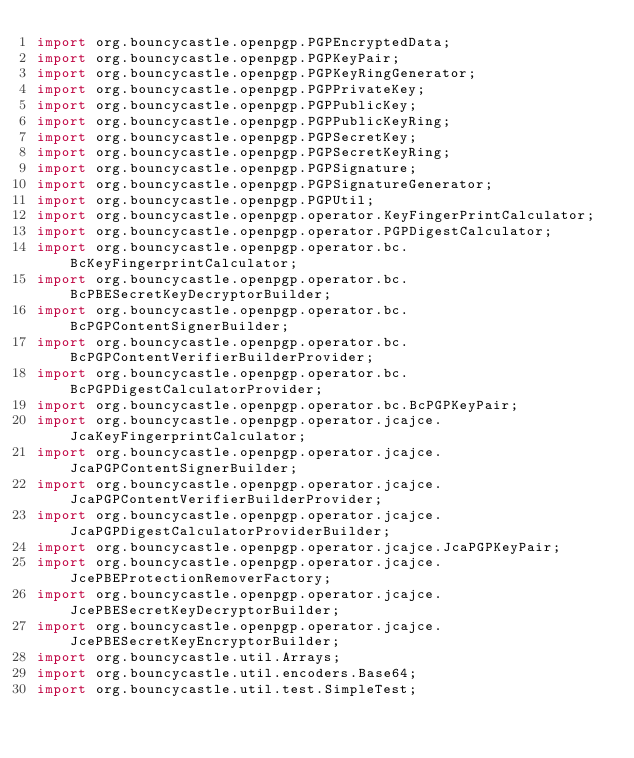<code> <loc_0><loc_0><loc_500><loc_500><_Java_>import org.bouncycastle.openpgp.PGPEncryptedData;
import org.bouncycastle.openpgp.PGPKeyPair;
import org.bouncycastle.openpgp.PGPKeyRingGenerator;
import org.bouncycastle.openpgp.PGPPrivateKey;
import org.bouncycastle.openpgp.PGPPublicKey;
import org.bouncycastle.openpgp.PGPPublicKeyRing;
import org.bouncycastle.openpgp.PGPSecretKey;
import org.bouncycastle.openpgp.PGPSecretKeyRing;
import org.bouncycastle.openpgp.PGPSignature;
import org.bouncycastle.openpgp.PGPSignatureGenerator;
import org.bouncycastle.openpgp.PGPUtil;
import org.bouncycastle.openpgp.operator.KeyFingerPrintCalculator;
import org.bouncycastle.openpgp.operator.PGPDigestCalculator;
import org.bouncycastle.openpgp.operator.bc.BcKeyFingerprintCalculator;
import org.bouncycastle.openpgp.operator.bc.BcPBESecretKeyDecryptorBuilder;
import org.bouncycastle.openpgp.operator.bc.BcPGPContentSignerBuilder;
import org.bouncycastle.openpgp.operator.bc.BcPGPContentVerifierBuilderProvider;
import org.bouncycastle.openpgp.operator.bc.BcPGPDigestCalculatorProvider;
import org.bouncycastle.openpgp.operator.bc.BcPGPKeyPair;
import org.bouncycastle.openpgp.operator.jcajce.JcaKeyFingerprintCalculator;
import org.bouncycastle.openpgp.operator.jcajce.JcaPGPContentSignerBuilder;
import org.bouncycastle.openpgp.operator.jcajce.JcaPGPContentVerifierBuilderProvider;
import org.bouncycastle.openpgp.operator.jcajce.JcaPGPDigestCalculatorProviderBuilder;
import org.bouncycastle.openpgp.operator.jcajce.JcaPGPKeyPair;
import org.bouncycastle.openpgp.operator.jcajce.JcePBEProtectionRemoverFactory;
import org.bouncycastle.openpgp.operator.jcajce.JcePBESecretKeyDecryptorBuilder;
import org.bouncycastle.openpgp.operator.jcajce.JcePBESecretKeyEncryptorBuilder;
import org.bouncycastle.util.Arrays;
import org.bouncycastle.util.encoders.Base64;
import org.bouncycastle.util.test.SimpleTest;
</code> 